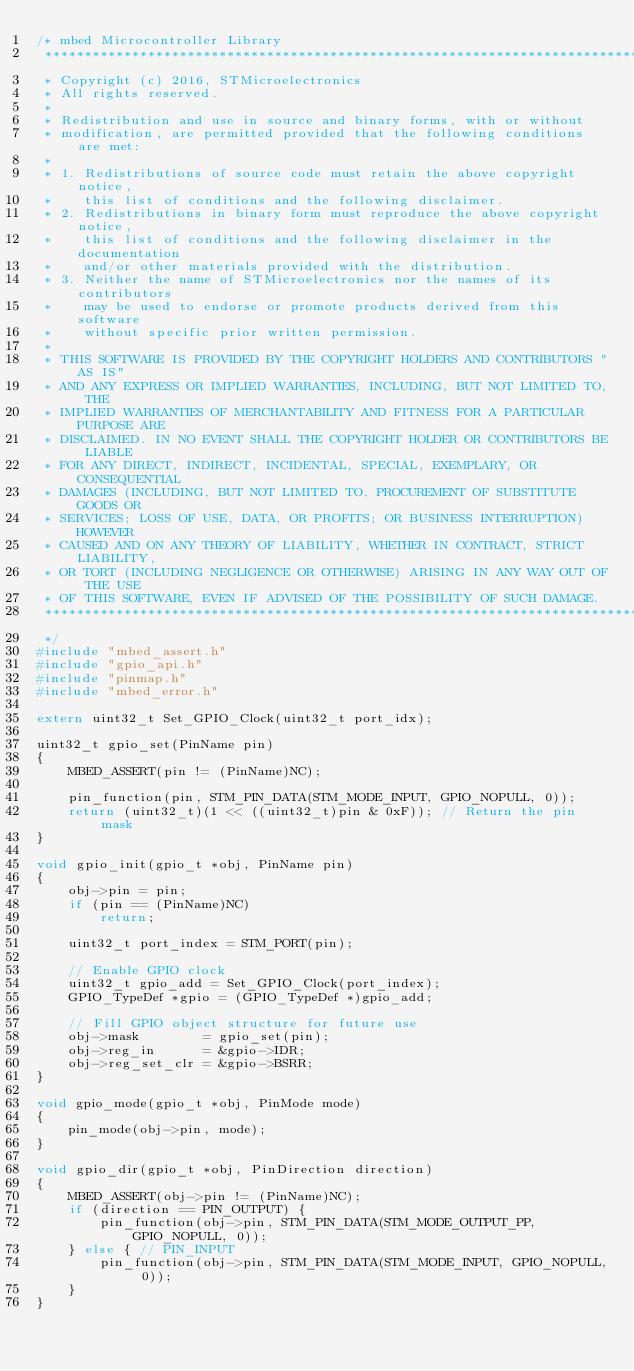<code> <loc_0><loc_0><loc_500><loc_500><_C_>/* mbed Microcontroller Library
 *******************************************************************************
 * Copyright (c) 2016, STMicroelectronics
 * All rights reserved.
 *
 * Redistribution and use in source and binary forms, with or without
 * modification, are permitted provided that the following conditions are met:
 *
 * 1. Redistributions of source code must retain the above copyright notice,
 *    this list of conditions and the following disclaimer.
 * 2. Redistributions in binary form must reproduce the above copyright notice,
 *    this list of conditions and the following disclaimer in the documentation
 *    and/or other materials provided with the distribution.
 * 3. Neither the name of STMicroelectronics nor the names of its contributors
 *    may be used to endorse or promote products derived from this software
 *    without specific prior written permission.
 *
 * THIS SOFTWARE IS PROVIDED BY THE COPYRIGHT HOLDERS AND CONTRIBUTORS "AS IS"
 * AND ANY EXPRESS OR IMPLIED WARRANTIES, INCLUDING, BUT NOT LIMITED TO, THE
 * IMPLIED WARRANTIES OF MERCHANTABILITY AND FITNESS FOR A PARTICULAR PURPOSE ARE
 * DISCLAIMED. IN NO EVENT SHALL THE COPYRIGHT HOLDER OR CONTRIBUTORS BE LIABLE
 * FOR ANY DIRECT, INDIRECT, INCIDENTAL, SPECIAL, EXEMPLARY, OR CONSEQUENTIAL
 * DAMAGES (INCLUDING, BUT NOT LIMITED TO, PROCUREMENT OF SUBSTITUTE GOODS OR
 * SERVICES; LOSS OF USE, DATA, OR PROFITS; OR BUSINESS INTERRUPTION) HOWEVER
 * CAUSED AND ON ANY THEORY OF LIABILITY, WHETHER IN CONTRACT, STRICT LIABILITY,
 * OR TORT (INCLUDING NEGLIGENCE OR OTHERWISE) ARISING IN ANY WAY OUT OF THE USE
 * OF THIS SOFTWARE, EVEN IF ADVISED OF THE POSSIBILITY OF SUCH DAMAGE.
 *******************************************************************************
 */
#include "mbed_assert.h"
#include "gpio_api.h"
#include "pinmap.h"
#include "mbed_error.h"

extern uint32_t Set_GPIO_Clock(uint32_t port_idx);

uint32_t gpio_set(PinName pin)
{
    MBED_ASSERT(pin != (PinName)NC);

    pin_function(pin, STM_PIN_DATA(STM_MODE_INPUT, GPIO_NOPULL, 0));
    return (uint32_t)(1 << ((uint32_t)pin & 0xF)); // Return the pin mask
}

void gpio_init(gpio_t *obj, PinName pin)
{
    obj->pin = pin;
    if (pin == (PinName)NC)
        return;

    uint32_t port_index = STM_PORT(pin);

    // Enable GPIO clock
    uint32_t gpio_add = Set_GPIO_Clock(port_index);
    GPIO_TypeDef *gpio = (GPIO_TypeDef *)gpio_add;

    // Fill GPIO object structure for future use
    obj->mask        = gpio_set(pin);
    obj->reg_in      = &gpio->IDR;
    obj->reg_set_clr = &gpio->BSRR;
}

void gpio_mode(gpio_t *obj, PinMode mode)
{
    pin_mode(obj->pin, mode);
}

void gpio_dir(gpio_t *obj, PinDirection direction)
{
    MBED_ASSERT(obj->pin != (PinName)NC);
    if (direction == PIN_OUTPUT) {
        pin_function(obj->pin, STM_PIN_DATA(STM_MODE_OUTPUT_PP, GPIO_NOPULL, 0));
    } else { // PIN_INPUT
        pin_function(obj->pin, STM_PIN_DATA(STM_MODE_INPUT, GPIO_NOPULL, 0));
    }
}
</code> 